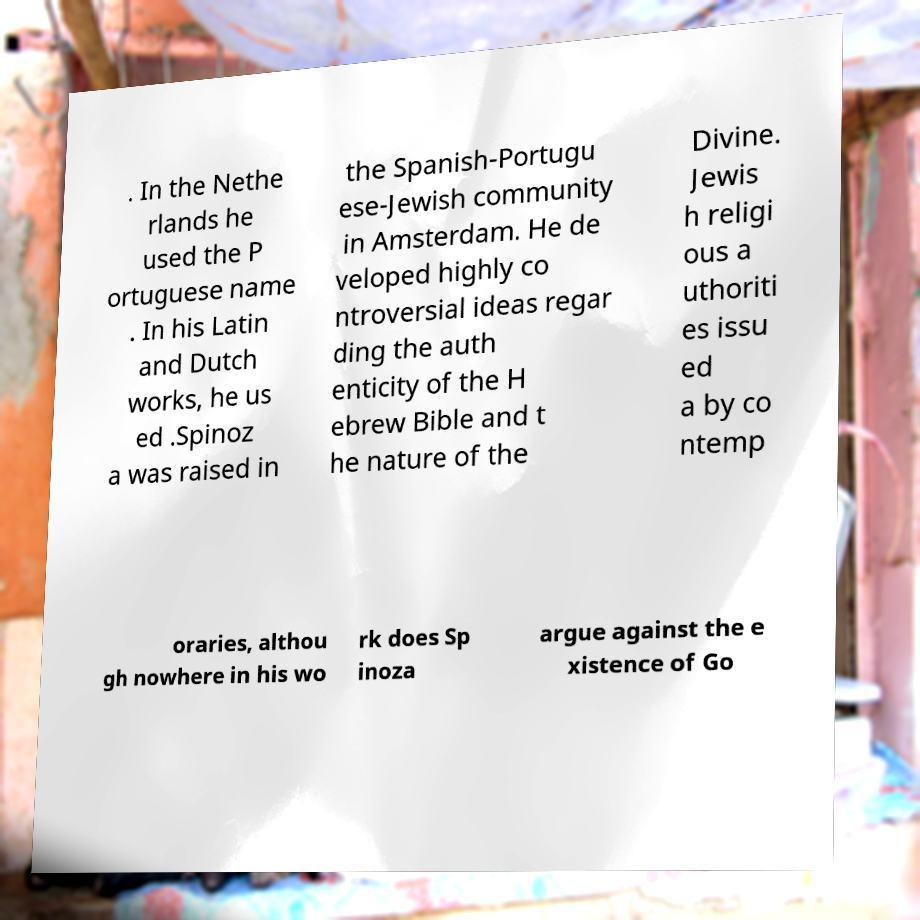Please identify and transcribe the text found in this image. . In the Nethe rlands he used the P ortuguese name . In his Latin and Dutch works, he us ed .Spinoz a was raised in the Spanish-Portugu ese-Jewish community in Amsterdam. He de veloped highly co ntroversial ideas regar ding the auth enticity of the H ebrew Bible and t he nature of the Divine. Jewis h religi ous a uthoriti es issu ed a by co ntemp oraries, althou gh nowhere in his wo rk does Sp inoza argue against the e xistence of Go 